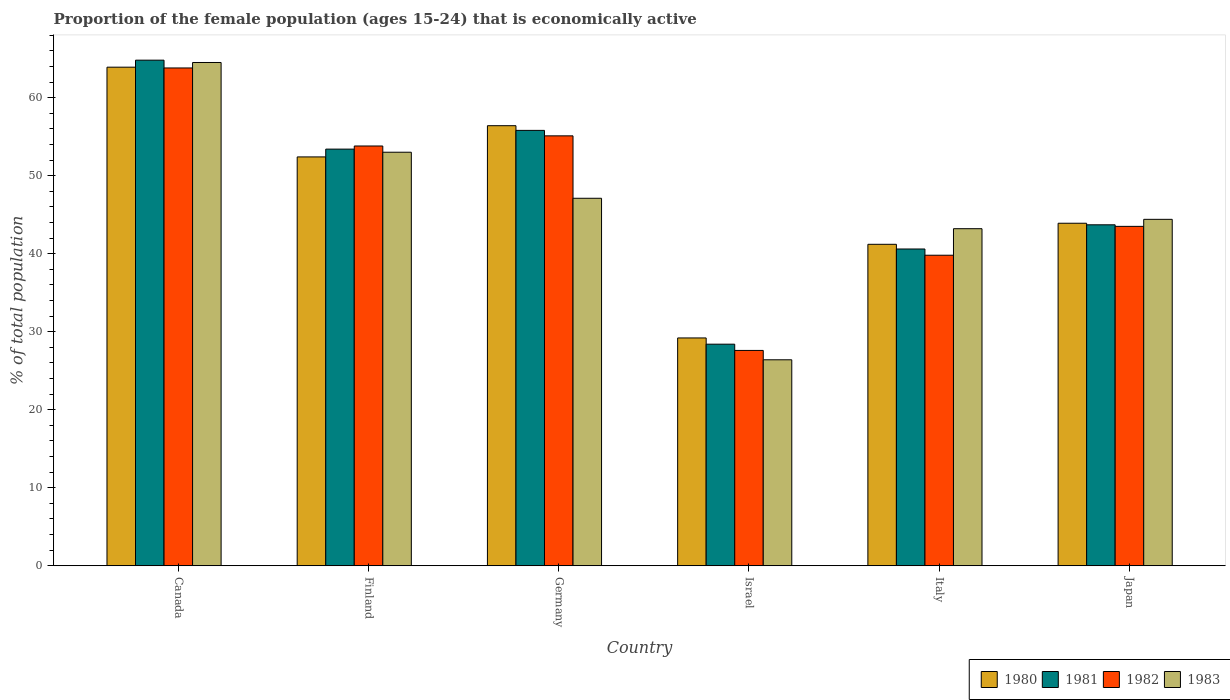How many different coloured bars are there?
Provide a succinct answer. 4. How many groups of bars are there?
Make the answer very short. 6. How many bars are there on the 2nd tick from the left?
Your response must be concise. 4. How many bars are there on the 4th tick from the right?
Your response must be concise. 4. What is the proportion of the female population that is economically active in 1983 in Canada?
Your answer should be very brief. 64.5. Across all countries, what is the maximum proportion of the female population that is economically active in 1983?
Offer a terse response. 64.5. Across all countries, what is the minimum proportion of the female population that is economically active in 1981?
Provide a short and direct response. 28.4. In which country was the proportion of the female population that is economically active in 1980 maximum?
Provide a short and direct response. Canada. In which country was the proportion of the female population that is economically active in 1983 minimum?
Your response must be concise. Israel. What is the total proportion of the female population that is economically active in 1980 in the graph?
Offer a very short reply. 287. What is the difference between the proportion of the female population that is economically active in 1980 in Germany and that in Italy?
Provide a succinct answer. 15.2. What is the difference between the proportion of the female population that is economically active in 1980 in Canada and the proportion of the female population that is economically active in 1981 in Germany?
Keep it short and to the point. 8.1. What is the average proportion of the female population that is economically active in 1982 per country?
Your answer should be very brief. 47.27. What is the difference between the proportion of the female population that is economically active of/in 1983 and proportion of the female population that is economically active of/in 1980 in Israel?
Your answer should be very brief. -2.8. In how many countries, is the proportion of the female population that is economically active in 1981 greater than 66 %?
Your response must be concise. 0. What is the ratio of the proportion of the female population that is economically active in 1980 in Canada to that in Germany?
Offer a terse response. 1.13. Is the proportion of the female population that is economically active in 1980 in Italy less than that in Japan?
Provide a short and direct response. Yes. Is the difference between the proportion of the female population that is economically active in 1983 in Germany and Israel greater than the difference between the proportion of the female population that is economically active in 1980 in Germany and Israel?
Ensure brevity in your answer.  No. What is the difference between the highest and the second highest proportion of the female population that is economically active in 1981?
Keep it short and to the point. 11.4. What is the difference between the highest and the lowest proportion of the female population that is economically active in 1980?
Offer a terse response. 34.7. In how many countries, is the proportion of the female population that is economically active in 1982 greater than the average proportion of the female population that is economically active in 1982 taken over all countries?
Provide a short and direct response. 3. What does the 2nd bar from the left in Japan represents?
Offer a terse response. 1981. Is it the case that in every country, the sum of the proportion of the female population that is economically active in 1982 and proportion of the female population that is economically active in 1981 is greater than the proportion of the female population that is economically active in 1980?
Your answer should be very brief. Yes. How many bars are there?
Keep it short and to the point. 24. Are all the bars in the graph horizontal?
Ensure brevity in your answer.  No. How many countries are there in the graph?
Your answer should be compact. 6. What is the difference between two consecutive major ticks on the Y-axis?
Make the answer very short. 10. Where does the legend appear in the graph?
Make the answer very short. Bottom right. How many legend labels are there?
Provide a short and direct response. 4. How are the legend labels stacked?
Offer a very short reply. Horizontal. What is the title of the graph?
Your response must be concise. Proportion of the female population (ages 15-24) that is economically active. What is the label or title of the Y-axis?
Provide a succinct answer. % of total population. What is the % of total population in 1980 in Canada?
Your answer should be compact. 63.9. What is the % of total population in 1981 in Canada?
Keep it short and to the point. 64.8. What is the % of total population in 1982 in Canada?
Offer a very short reply. 63.8. What is the % of total population of 1983 in Canada?
Make the answer very short. 64.5. What is the % of total population in 1980 in Finland?
Offer a terse response. 52.4. What is the % of total population in 1981 in Finland?
Your answer should be compact. 53.4. What is the % of total population of 1982 in Finland?
Your answer should be very brief. 53.8. What is the % of total population in 1983 in Finland?
Provide a succinct answer. 53. What is the % of total population in 1980 in Germany?
Your answer should be very brief. 56.4. What is the % of total population in 1981 in Germany?
Your answer should be compact. 55.8. What is the % of total population of 1982 in Germany?
Your answer should be very brief. 55.1. What is the % of total population in 1983 in Germany?
Your response must be concise. 47.1. What is the % of total population in 1980 in Israel?
Your answer should be very brief. 29.2. What is the % of total population of 1981 in Israel?
Provide a succinct answer. 28.4. What is the % of total population of 1982 in Israel?
Provide a succinct answer. 27.6. What is the % of total population in 1983 in Israel?
Ensure brevity in your answer.  26.4. What is the % of total population in 1980 in Italy?
Provide a short and direct response. 41.2. What is the % of total population in 1981 in Italy?
Provide a short and direct response. 40.6. What is the % of total population of 1982 in Italy?
Provide a succinct answer. 39.8. What is the % of total population of 1983 in Italy?
Ensure brevity in your answer.  43.2. What is the % of total population in 1980 in Japan?
Make the answer very short. 43.9. What is the % of total population in 1981 in Japan?
Ensure brevity in your answer.  43.7. What is the % of total population in 1982 in Japan?
Your response must be concise. 43.5. What is the % of total population of 1983 in Japan?
Provide a succinct answer. 44.4. Across all countries, what is the maximum % of total population in 1980?
Offer a terse response. 63.9. Across all countries, what is the maximum % of total population of 1981?
Your answer should be very brief. 64.8. Across all countries, what is the maximum % of total population in 1982?
Provide a succinct answer. 63.8. Across all countries, what is the maximum % of total population in 1983?
Provide a short and direct response. 64.5. Across all countries, what is the minimum % of total population in 1980?
Keep it short and to the point. 29.2. Across all countries, what is the minimum % of total population of 1981?
Your answer should be very brief. 28.4. Across all countries, what is the minimum % of total population in 1982?
Give a very brief answer. 27.6. Across all countries, what is the minimum % of total population in 1983?
Provide a short and direct response. 26.4. What is the total % of total population in 1980 in the graph?
Give a very brief answer. 287. What is the total % of total population of 1981 in the graph?
Your answer should be very brief. 286.7. What is the total % of total population in 1982 in the graph?
Your answer should be very brief. 283.6. What is the total % of total population in 1983 in the graph?
Keep it short and to the point. 278.6. What is the difference between the % of total population of 1981 in Canada and that in Germany?
Ensure brevity in your answer.  9. What is the difference between the % of total population of 1982 in Canada and that in Germany?
Offer a very short reply. 8.7. What is the difference between the % of total population in 1983 in Canada and that in Germany?
Your response must be concise. 17.4. What is the difference between the % of total population of 1980 in Canada and that in Israel?
Your answer should be compact. 34.7. What is the difference between the % of total population of 1981 in Canada and that in Israel?
Ensure brevity in your answer.  36.4. What is the difference between the % of total population in 1982 in Canada and that in Israel?
Keep it short and to the point. 36.2. What is the difference between the % of total population in 1983 in Canada and that in Israel?
Your answer should be very brief. 38.1. What is the difference between the % of total population of 1980 in Canada and that in Italy?
Provide a short and direct response. 22.7. What is the difference between the % of total population in 1981 in Canada and that in Italy?
Offer a terse response. 24.2. What is the difference between the % of total population of 1982 in Canada and that in Italy?
Offer a very short reply. 24. What is the difference between the % of total population of 1983 in Canada and that in Italy?
Offer a very short reply. 21.3. What is the difference between the % of total population in 1981 in Canada and that in Japan?
Ensure brevity in your answer.  21.1. What is the difference between the % of total population in 1982 in Canada and that in Japan?
Your answer should be compact. 20.3. What is the difference between the % of total population in 1983 in Canada and that in Japan?
Keep it short and to the point. 20.1. What is the difference between the % of total population of 1980 in Finland and that in Germany?
Your answer should be very brief. -4. What is the difference between the % of total population of 1980 in Finland and that in Israel?
Your answer should be compact. 23.2. What is the difference between the % of total population of 1982 in Finland and that in Israel?
Ensure brevity in your answer.  26.2. What is the difference between the % of total population of 1983 in Finland and that in Israel?
Give a very brief answer. 26.6. What is the difference between the % of total population in 1981 in Finland and that in Italy?
Your answer should be very brief. 12.8. What is the difference between the % of total population of 1982 in Finland and that in Italy?
Ensure brevity in your answer.  14. What is the difference between the % of total population in 1983 in Finland and that in Italy?
Give a very brief answer. 9.8. What is the difference between the % of total population in 1981 in Finland and that in Japan?
Make the answer very short. 9.7. What is the difference between the % of total population in 1983 in Finland and that in Japan?
Ensure brevity in your answer.  8.6. What is the difference between the % of total population of 1980 in Germany and that in Israel?
Your response must be concise. 27.2. What is the difference between the % of total population of 1981 in Germany and that in Israel?
Provide a short and direct response. 27.4. What is the difference between the % of total population of 1982 in Germany and that in Israel?
Keep it short and to the point. 27.5. What is the difference between the % of total population in 1983 in Germany and that in Israel?
Make the answer very short. 20.7. What is the difference between the % of total population of 1981 in Germany and that in Italy?
Give a very brief answer. 15.2. What is the difference between the % of total population of 1982 in Germany and that in Italy?
Your response must be concise. 15.3. What is the difference between the % of total population in 1982 in Germany and that in Japan?
Keep it short and to the point. 11.6. What is the difference between the % of total population of 1983 in Israel and that in Italy?
Your answer should be very brief. -16.8. What is the difference between the % of total population of 1980 in Israel and that in Japan?
Your answer should be compact. -14.7. What is the difference between the % of total population of 1981 in Israel and that in Japan?
Make the answer very short. -15.3. What is the difference between the % of total population of 1982 in Israel and that in Japan?
Your answer should be compact. -15.9. What is the difference between the % of total population of 1983 in Israel and that in Japan?
Your answer should be very brief. -18. What is the difference between the % of total population of 1981 in Italy and that in Japan?
Your answer should be very brief. -3.1. What is the difference between the % of total population of 1980 in Canada and the % of total population of 1981 in Finland?
Your answer should be compact. 10.5. What is the difference between the % of total population in 1980 in Canada and the % of total population in 1981 in Germany?
Ensure brevity in your answer.  8.1. What is the difference between the % of total population in 1980 in Canada and the % of total population in 1982 in Germany?
Make the answer very short. 8.8. What is the difference between the % of total population in 1981 in Canada and the % of total population in 1982 in Germany?
Provide a short and direct response. 9.7. What is the difference between the % of total population in 1981 in Canada and the % of total population in 1983 in Germany?
Offer a terse response. 17.7. What is the difference between the % of total population of 1982 in Canada and the % of total population of 1983 in Germany?
Your answer should be very brief. 16.7. What is the difference between the % of total population in 1980 in Canada and the % of total population in 1981 in Israel?
Provide a succinct answer. 35.5. What is the difference between the % of total population in 1980 in Canada and the % of total population in 1982 in Israel?
Give a very brief answer. 36.3. What is the difference between the % of total population in 1980 in Canada and the % of total population in 1983 in Israel?
Make the answer very short. 37.5. What is the difference between the % of total population of 1981 in Canada and the % of total population of 1982 in Israel?
Give a very brief answer. 37.2. What is the difference between the % of total population in 1981 in Canada and the % of total population in 1983 in Israel?
Your answer should be very brief. 38.4. What is the difference between the % of total population of 1982 in Canada and the % of total population of 1983 in Israel?
Your response must be concise. 37.4. What is the difference between the % of total population of 1980 in Canada and the % of total population of 1981 in Italy?
Your response must be concise. 23.3. What is the difference between the % of total population in 1980 in Canada and the % of total population in 1982 in Italy?
Provide a succinct answer. 24.1. What is the difference between the % of total population in 1980 in Canada and the % of total population in 1983 in Italy?
Your answer should be very brief. 20.7. What is the difference between the % of total population in 1981 in Canada and the % of total population in 1983 in Italy?
Offer a very short reply. 21.6. What is the difference between the % of total population of 1982 in Canada and the % of total population of 1983 in Italy?
Make the answer very short. 20.6. What is the difference between the % of total population of 1980 in Canada and the % of total population of 1981 in Japan?
Give a very brief answer. 20.2. What is the difference between the % of total population of 1980 in Canada and the % of total population of 1982 in Japan?
Make the answer very short. 20.4. What is the difference between the % of total population in 1981 in Canada and the % of total population in 1982 in Japan?
Ensure brevity in your answer.  21.3. What is the difference between the % of total population of 1981 in Canada and the % of total population of 1983 in Japan?
Give a very brief answer. 20.4. What is the difference between the % of total population of 1982 in Canada and the % of total population of 1983 in Japan?
Your answer should be very brief. 19.4. What is the difference between the % of total population in 1980 in Finland and the % of total population in 1982 in Germany?
Make the answer very short. -2.7. What is the difference between the % of total population in 1981 in Finland and the % of total population in 1982 in Germany?
Your response must be concise. -1.7. What is the difference between the % of total population in 1980 in Finland and the % of total population in 1981 in Israel?
Provide a short and direct response. 24. What is the difference between the % of total population of 1980 in Finland and the % of total population of 1982 in Israel?
Provide a succinct answer. 24.8. What is the difference between the % of total population of 1981 in Finland and the % of total population of 1982 in Israel?
Your answer should be very brief. 25.8. What is the difference between the % of total population of 1981 in Finland and the % of total population of 1983 in Israel?
Your answer should be very brief. 27. What is the difference between the % of total population of 1982 in Finland and the % of total population of 1983 in Israel?
Give a very brief answer. 27.4. What is the difference between the % of total population in 1980 in Finland and the % of total population in 1981 in Italy?
Make the answer very short. 11.8. What is the difference between the % of total population of 1980 in Finland and the % of total population of 1982 in Italy?
Give a very brief answer. 12.6. What is the difference between the % of total population in 1980 in Finland and the % of total population in 1983 in Italy?
Your response must be concise. 9.2. What is the difference between the % of total population of 1982 in Finland and the % of total population of 1983 in Italy?
Offer a very short reply. 10.6. What is the difference between the % of total population in 1981 in Finland and the % of total population in 1983 in Japan?
Your response must be concise. 9. What is the difference between the % of total population in 1980 in Germany and the % of total population in 1981 in Israel?
Offer a terse response. 28. What is the difference between the % of total population in 1980 in Germany and the % of total population in 1982 in Israel?
Offer a terse response. 28.8. What is the difference between the % of total population of 1981 in Germany and the % of total population of 1982 in Israel?
Ensure brevity in your answer.  28.2. What is the difference between the % of total population of 1981 in Germany and the % of total population of 1983 in Israel?
Give a very brief answer. 29.4. What is the difference between the % of total population in 1982 in Germany and the % of total population in 1983 in Israel?
Offer a terse response. 28.7. What is the difference between the % of total population of 1980 in Germany and the % of total population of 1981 in Italy?
Provide a short and direct response. 15.8. What is the difference between the % of total population of 1980 in Germany and the % of total population of 1982 in Italy?
Your answer should be very brief. 16.6. What is the difference between the % of total population of 1981 in Germany and the % of total population of 1983 in Italy?
Your answer should be very brief. 12.6. What is the difference between the % of total population of 1982 in Germany and the % of total population of 1983 in Italy?
Keep it short and to the point. 11.9. What is the difference between the % of total population in 1980 in Germany and the % of total population in 1981 in Japan?
Make the answer very short. 12.7. What is the difference between the % of total population in 1980 in Germany and the % of total population in 1982 in Japan?
Offer a very short reply. 12.9. What is the difference between the % of total population in 1980 in Germany and the % of total population in 1983 in Japan?
Your answer should be compact. 12. What is the difference between the % of total population of 1980 in Israel and the % of total population of 1981 in Italy?
Ensure brevity in your answer.  -11.4. What is the difference between the % of total population in 1980 in Israel and the % of total population in 1982 in Italy?
Provide a succinct answer. -10.6. What is the difference between the % of total population in 1980 in Israel and the % of total population in 1983 in Italy?
Your answer should be compact. -14. What is the difference between the % of total population of 1981 in Israel and the % of total population of 1982 in Italy?
Offer a very short reply. -11.4. What is the difference between the % of total population of 1981 in Israel and the % of total population of 1983 in Italy?
Your answer should be very brief. -14.8. What is the difference between the % of total population in 1982 in Israel and the % of total population in 1983 in Italy?
Your answer should be very brief. -15.6. What is the difference between the % of total population of 1980 in Israel and the % of total population of 1981 in Japan?
Offer a very short reply. -14.5. What is the difference between the % of total population of 1980 in Israel and the % of total population of 1982 in Japan?
Keep it short and to the point. -14.3. What is the difference between the % of total population in 1980 in Israel and the % of total population in 1983 in Japan?
Offer a terse response. -15.2. What is the difference between the % of total population in 1981 in Israel and the % of total population in 1982 in Japan?
Your response must be concise. -15.1. What is the difference between the % of total population in 1982 in Israel and the % of total population in 1983 in Japan?
Provide a short and direct response. -16.8. What is the difference between the % of total population of 1980 in Italy and the % of total population of 1981 in Japan?
Provide a short and direct response. -2.5. What is the difference between the % of total population of 1980 in Italy and the % of total population of 1982 in Japan?
Keep it short and to the point. -2.3. What is the difference between the % of total population in 1982 in Italy and the % of total population in 1983 in Japan?
Keep it short and to the point. -4.6. What is the average % of total population in 1980 per country?
Your answer should be compact. 47.83. What is the average % of total population in 1981 per country?
Offer a very short reply. 47.78. What is the average % of total population of 1982 per country?
Make the answer very short. 47.27. What is the average % of total population of 1983 per country?
Your response must be concise. 46.43. What is the difference between the % of total population in 1980 and % of total population in 1981 in Canada?
Offer a terse response. -0.9. What is the difference between the % of total population of 1980 and % of total population of 1982 in Canada?
Offer a very short reply. 0.1. What is the difference between the % of total population of 1980 and % of total population of 1983 in Canada?
Offer a very short reply. -0.6. What is the difference between the % of total population in 1981 and % of total population in 1982 in Canada?
Give a very brief answer. 1. What is the difference between the % of total population in 1982 and % of total population in 1983 in Canada?
Make the answer very short. -0.7. What is the difference between the % of total population of 1980 and % of total population of 1982 in Finland?
Provide a succinct answer. -1.4. What is the difference between the % of total population in 1981 and % of total population in 1983 in Finland?
Give a very brief answer. 0.4. What is the difference between the % of total population in 1980 and % of total population in 1982 in Germany?
Give a very brief answer. 1.3. What is the difference between the % of total population in 1981 and % of total population in 1982 in Germany?
Ensure brevity in your answer.  0.7. What is the difference between the % of total population in 1982 and % of total population in 1983 in Germany?
Keep it short and to the point. 8. What is the difference between the % of total population of 1980 and % of total population of 1981 in Israel?
Your response must be concise. 0.8. What is the difference between the % of total population in 1980 and % of total population in 1982 in Israel?
Your answer should be compact. 1.6. What is the difference between the % of total population in 1981 and % of total population in 1983 in Israel?
Offer a very short reply. 2. What is the difference between the % of total population in 1980 and % of total population in 1981 in Italy?
Your answer should be very brief. 0.6. What is the difference between the % of total population in 1980 and % of total population in 1983 in Italy?
Your answer should be very brief. -2. What is the difference between the % of total population in 1981 and % of total population in 1982 in Italy?
Provide a short and direct response. 0.8. What is the difference between the % of total population in 1982 and % of total population in 1983 in Italy?
Your answer should be very brief. -3.4. What is the difference between the % of total population in 1980 and % of total population in 1981 in Japan?
Ensure brevity in your answer.  0.2. What is the difference between the % of total population of 1980 and % of total population of 1982 in Japan?
Keep it short and to the point. 0.4. What is the difference between the % of total population in 1980 and % of total population in 1983 in Japan?
Your response must be concise. -0.5. What is the difference between the % of total population of 1981 and % of total population of 1982 in Japan?
Your response must be concise. 0.2. What is the difference between the % of total population of 1981 and % of total population of 1983 in Japan?
Ensure brevity in your answer.  -0.7. What is the difference between the % of total population in 1982 and % of total population in 1983 in Japan?
Your response must be concise. -0.9. What is the ratio of the % of total population in 1980 in Canada to that in Finland?
Provide a succinct answer. 1.22. What is the ratio of the % of total population in 1981 in Canada to that in Finland?
Your answer should be compact. 1.21. What is the ratio of the % of total population in 1982 in Canada to that in Finland?
Provide a short and direct response. 1.19. What is the ratio of the % of total population of 1983 in Canada to that in Finland?
Offer a terse response. 1.22. What is the ratio of the % of total population in 1980 in Canada to that in Germany?
Ensure brevity in your answer.  1.13. What is the ratio of the % of total population of 1981 in Canada to that in Germany?
Offer a very short reply. 1.16. What is the ratio of the % of total population of 1982 in Canada to that in Germany?
Your response must be concise. 1.16. What is the ratio of the % of total population in 1983 in Canada to that in Germany?
Your response must be concise. 1.37. What is the ratio of the % of total population in 1980 in Canada to that in Israel?
Your response must be concise. 2.19. What is the ratio of the % of total population of 1981 in Canada to that in Israel?
Keep it short and to the point. 2.28. What is the ratio of the % of total population in 1982 in Canada to that in Israel?
Make the answer very short. 2.31. What is the ratio of the % of total population of 1983 in Canada to that in Israel?
Your response must be concise. 2.44. What is the ratio of the % of total population in 1980 in Canada to that in Italy?
Offer a terse response. 1.55. What is the ratio of the % of total population of 1981 in Canada to that in Italy?
Make the answer very short. 1.6. What is the ratio of the % of total population in 1982 in Canada to that in Italy?
Keep it short and to the point. 1.6. What is the ratio of the % of total population of 1983 in Canada to that in Italy?
Your answer should be compact. 1.49. What is the ratio of the % of total population in 1980 in Canada to that in Japan?
Offer a very short reply. 1.46. What is the ratio of the % of total population in 1981 in Canada to that in Japan?
Your answer should be very brief. 1.48. What is the ratio of the % of total population of 1982 in Canada to that in Japan?
Offer a terse response. 1.47. What is the ratio of the % of total population in 1983 in Canada to that in Japan?
Offer a terse response. 1.45. What is the ratio of the % of total population in 1980 in Finland to that in Germany?
Your answer should be very brief. 0.93. What is the ratio of the % of total population in 1981 in Finland to that in Germany?
Your answer should be very brief. 0.96. What is the ratio of the % of total population in 1982 in Finland to that in Germany?
Give a very brief answer. 0.98. What is the ratio of the % of total population of 1983 in Finland to that in Germany?
Ensure brevity in your answer.  1.13. What is the ratio of the % of total population in 1980 in Finland to that in Israel?
Your answer should be compact. 1.79. What is the ratio of the % of total population in 1981 in Finland to that in Israel?
Offer a terse response. 1.88. What is the ratio of the % of total population in 1982 in Finland to that in Israel?
Ensure brevity in your answer.  1.95. What is the ratio of the % of total population of 1983 in Finland to that in Israel?
Your response must be concise. 2.01. What is the ratio of the % of total population of 1980 in Finland to that in Italy?
Your response must be concise. 1.27. What is the ratio of the % of total population in 1981 in Finland to that in Italy?
Make the answer very short. 1.32. What is the ratio of the % of total population in 1982 in Finland to that in Italy?
Provide a short and direct response. 1.35. What is the ratio of the % of total population in 1983 in Finland to that in Italy?
Provide a short and direct response. 1.23. What is the ratio of the % of total population in 1980 in Finland to that in Japan?
Keep it short and to the point. 1.19. What is the ratio of the % of total population in 1981 in Finland to that in Japan?
Give a very brief answer. 1.22. What is the ratio of the % of total population in 1982 in Finland to that in Japan?
Make the answer very short. 1.24. What is the ratio of the % of total population in 1983 in Finland to that in Japan?
Make the answer very short. 1.19. What is the ratio of the % of total population of 1980 in Germany to that in Israel?
Give a very brief answer. 1.93. What is the ratio of the % of total population of 1981 in Germany to that in Israel?
Keep it short and to the point. 1.96. What is the ratio of the % of total population in 1982 in Germany to that in Israel?
Make the answer very short. 2. What is the ratio of the % of total population of 1983 in Germany to that in Israel?
Offer a very short reply. 1.78. What is the ratio of the % of total population of 1980 in Germany to that in Italy?
Keep it short and to the point. 1.37. What is the ratio of the % of total population in 1981 in Germany to that in Italy?
Keep it short and to the point. 1.37. What is the ratio of the % of total population of 1982 in Germany to that in Italy?
Keep it short and to the point. 1.38. What is the ratio of the % of total population of 1983 in Germany to that in Italy?
Make the answer very short. 1.09. What is the ratio of the % of total population in 1980 in Germany to that in Japan?
Your response must be concise. 1.28. What is the ratio of the % of total population in 1981 in Germany to that in Japan?
Offer a very short reply. 1.28. What is the ratio of the % of total population of 1982 in Germany to that in Japan?
Ensure brevity in your answer.  1.27. What is the ratio of the % of total population of 1983 in Germany to that in Japan?
Give a very brief answer. 1.06. What is the ratio of the % of total population in 1980 in Israel to that in Italy?
Ensure brevity in your answer.  0.71. What is the ratio of the % of total population in 1981 in Israel to that in Italy?
Keep it short and to the point. 0.7. What is the ratio of the % of total population of 1982 in Israel to that in Italy?
Your response must be concise. 0.69. What is the ratio of the % of total population of 1983 in Israel to that in Italy?
Make the answer very short. 0.61. What is the ratio of the % of total population of 1980 in Israel to that in Japan?
Offer a very short reply. 0.67. What is the ratio of the % of total population in 1981 in Israel to that in Japan?
Your answer should be very brief. 0.65. What is the ratio of the % of total population of 1982 in Israel to that in Japan?
Keep it short and to the point. 0.63. What is the ratio of the % of total population of 1983 in Israel to that in Japan?
Your response must be concise. 0.59. What is the ratio of the % of total population of 1980 in Italy to that in Japan?
Offer a terse response. 0.94. What is the ratio of the % of total population in 1981 in Italy to that in Japan?
Offer a very short reply. 0.93. What is the ratio of the % of total population of 1982 in Italy to that in Japan?
Provide a short and direct response. 0.91. What is the difference between the highest and the second highest % of total population of 1982?
Offer a terse response. 8.7. What is the difference between the highest and the lowest % of total population in 1980?
Provide a short and direct response. 34.7. What is the difference between the highest and the lowest % of total population of 1981?
Your response must be concise. 36.4. What is the difference between the highest and the lowest % of total population in 1982?
Provide a short and direct response. 36.2. What is the difference between the highest and the lowest % of total population of 1983?
Your answer should be compact. 38.1. 